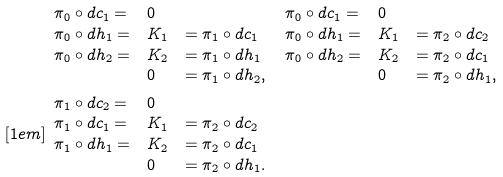Convert formula to latex. <formula><loc_0><loc_0><loc_500><loc_500>& \begin{array} { l l l } \pi _ { 0 } \circ d c _ { 1 } = & 0 & \\ \pi _ { 0 } \circ d h _ { 1 } = & K _ { 1 } & = \pi _ { 1 } \circ d c _ { 1 } \\ \pi _ { 0 } \circ d h _ { 2 } = & K _ { 2 } & = \pi _ { 1 } \circ d h _ { 1 } \\ & 0 & = \pi _ { 1 } \circ d h _ { 2 } , \end{array} \, \begin{array} { l l l } \pi _ { 0 } \circ d c _ { 1 } = & 0 & \\ \pi _ { 0 } \circ d h _ { 1 } = & K _ { 1 } & = \pi _ { 2 } \circ d c _ { 2 } \\ \pi _ { 0 } \circ d h _ { 2 } = & K _ { 2 } & = \pi _ { 2 } \circ d c _ { 1 } \\ & 0 & = \pi _ { 2 } \circ d h _ { 1 } , \end{array} \, \\ [ 1 e m ] & \begin{array} { l l l } \pi _ { 1 } \circ d c _ { 2 } = & 0 & \\ \pi _ { 1 } \circ d c _ { 1 } = & K _ { 1 } & = \pi _ { 2 } \circ d c _ { 2 } \\ \pi _ { 1 } \circ d h _ { 1 } = & K _ { 2 } & = \pi _ { 2 } \circ d c _ { 1 } \\ & 0 & = \pi _ { 2 } \circ d h _ { 1 } . \end{array}</formula> 